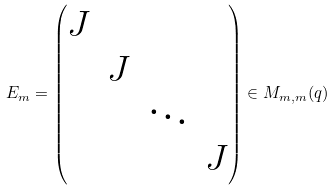<formula> <loc_0><loc_0><loc_500><loc_500>E _ { m } = \begin{pmatrix} J \\ & J \\ & & \ddots \\ & & & J \end{pmatrix} \in M _ { m , m } ( q )</formula> 